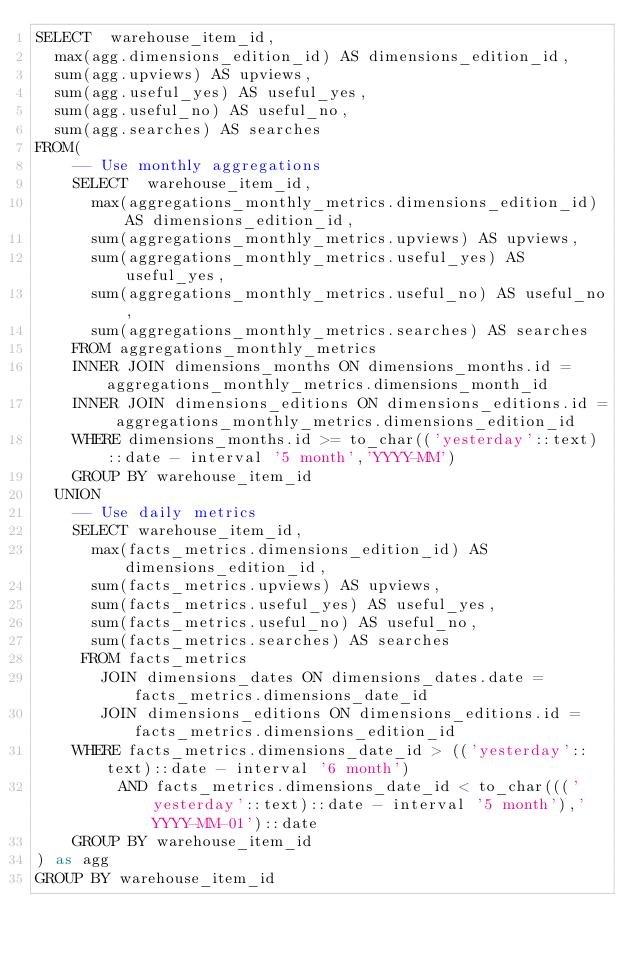<code> <loc_0><loc_0><loc_500><loc_500><_SQL_>SELECT  warehouse_item_id,
  max(agg.dimensions_edition_id) AS dimensions_edition_id,
  sum(agg.upviews) AS upviews,
  sum(agg.useful_yes) AS useful_yes,
  sum(agg.useful_no) AS useful_no,
  sum(agg.searches) AS searches
FROM(
    -- Use monthly aggregations
    SELECT  warehouse_item_id,
      max(aggregations_monthly_metrics.dimensions_edition_id) AS dimensions_edition_id,
      sum(aggregations_monthly_metrics.upviews) AS upviews,
      sum(aggregations_monthly_metrics.useful_yes) AS useful_yes,
      sum(aggregations_monthly_metrics.useful_no) AS useful_no,
      sum(aggregations_monthly_metrics.searches) AS searches
    FROM aggregations_monthly_metrics
    INNER JOIN dimensions_months ON dimensions_months.id = aggregations_monthly_metrics.dimensions_month_id
    INNER JOIN dimensions_editions ON dimensions_editions.id = aggregations_monthly_metrics.dimensions_edition_id
    WHERE dimensions_months.id >= to_char(('yesterday'::text)::date - interval '5 month','YYYY-MM')
    GROUP BY warehouse_item_id
  UNION
    -- Use daily metrics
    SELECT warehouse_item_id,
      max(facts_metrics.dimensions_edition_id) AS dimensions_edition_id,
      sum(facts_metrics.upviews) AS upviews,
      sum(facts_metrics.useful_yes) AS useful_yes,
      sum(facts_metrics.useful_no) AS useful_no,
      sum(facts_metrics.searches) AS searches
     FROM facts_metrics
       JOIN dimensions_dates ON dimensions_dates.date = facts_metrics.dimensions_date_id
       JOIN dimensions_editions ON dimensions_editions.id = facts_metrics.dimensions_edition_id
    WHERE facts_metrics.dimensions_date_id > (('yesterday'::text)::date - interval '6 month')
         AND facts_metrics.dimensions_date_id < to_char((('yesterday'::text)::date - interval '5 month'),'YYYY-MM-01')::date
    GROUP BY warehouse_item_id
) as agg
GROUP BY warehouse_item_id
</code> 